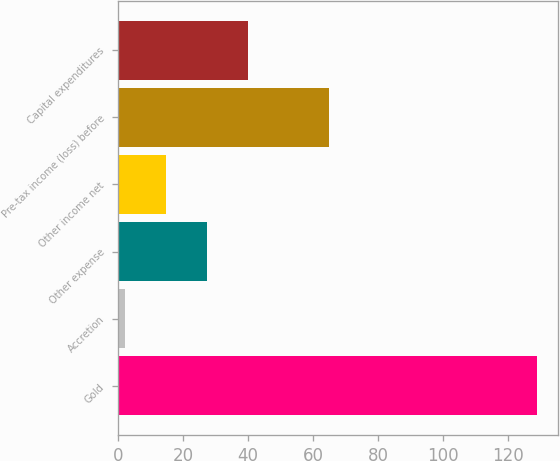Convert chart. <chart><loc_0><loc_0><loc_500><loc_500><bar_chart><fcel>Gold<fcel>Accretion<fcel>Other expense<fcel>Other income net<fcel>Pre-tax income (loss) before<fcel>Capital expenditures<nl><fcel>129<fcel>2<fcel>27.4<fcel>14.7<fcel>65<fcel>40.1<nl></chart> 